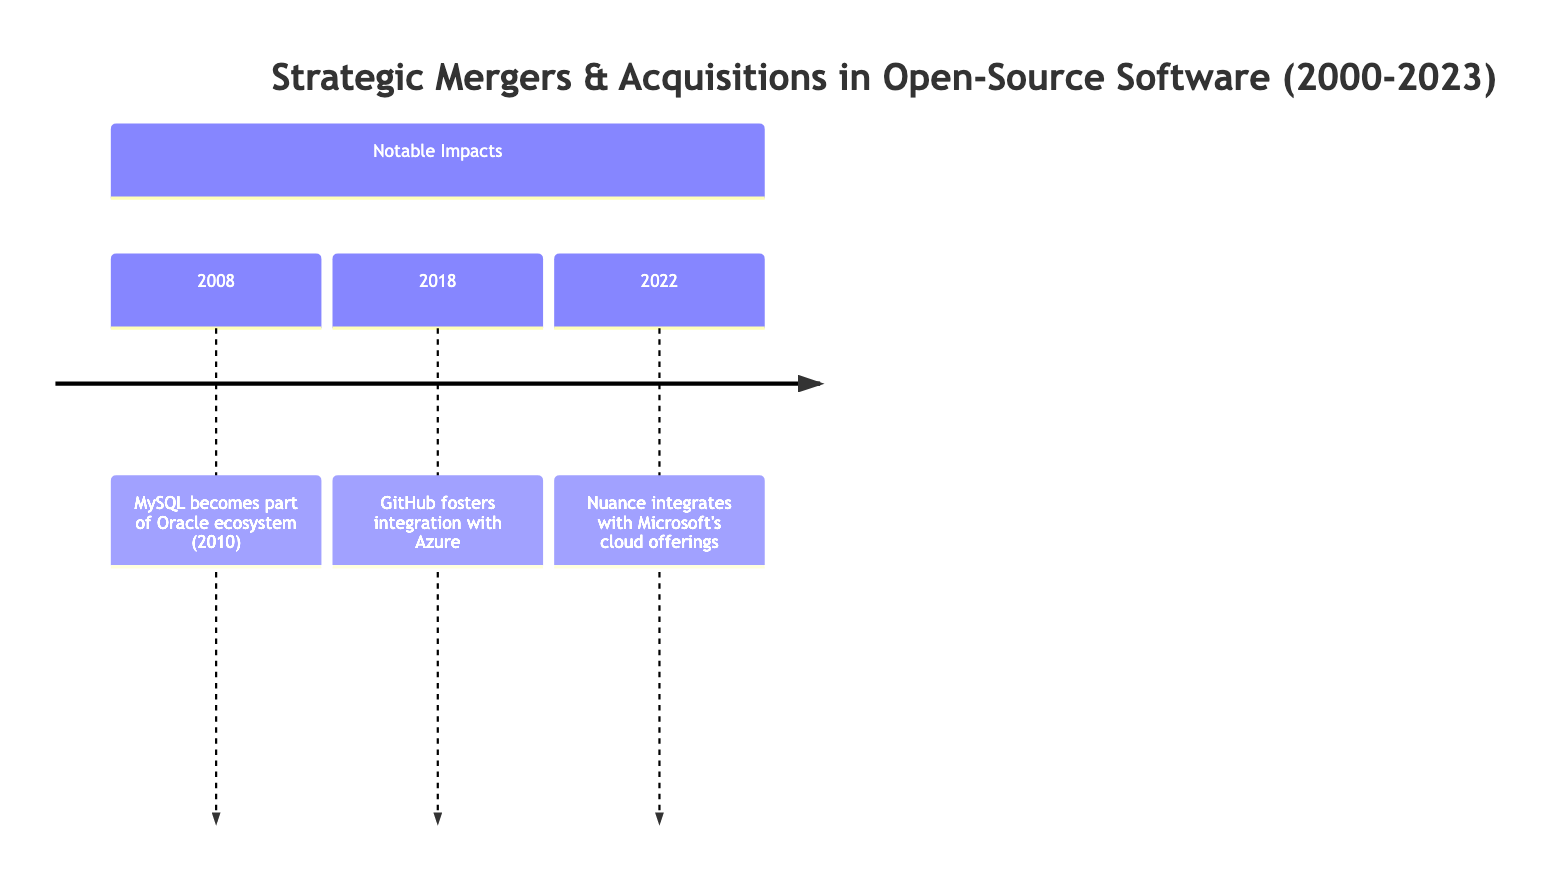What year did IBM acquire Informix? The timeline indicates that IBM acquired Informix in the year 2001.
Answer: 2001 What was the impact of Microsoft's acquisition of GitHub? The diagram states that Microsoft's acquisition of GitHub expanded developer tools and cloud services, facilitating greater integration with Azure and other Microsoft services.
Answer: Expanded developer tools and services How many acquisitions did Microsoft make in this timeline? Upon reviewing the timeline, Microsoft made three acquisitions: Revolution Analytics in 2015, GitHub in 2018, and Nuance Communications in 2022.
Answer: 3 Which company was acquired by Sun Microsystems? The timeline shows that Sun Microsystems acquired MySQL AB in 2008.
Answer: MySQL AB What was a notable impact of IBM’s acquisition of Red Hat? According to the diagram, IBM's $34 billion acquisition of Red Hat significantly bolstered IBM's hybrid cloud solutions, reshaping enterprise cloud services.
Answer: Reshaping enterprise cloud services What year did Red Hat acquire eNovance? The timeline indicates that Red Hat acquired eNovance in 2014.
Answer: 2014 What was the purpose of VMware acquiring SpringSource in 2010? From the timeline, VMware’s acquisition of SpringSource was aimed at expanding its open-source software capabilities, particularly improving cloud computing and enterprise solutions.
Answer: Expanding cloud computing capabilities Which acquisition marked a significant transformation in the database market in 2008? The timeline remarks that Sun Microsystems' acquisition of MySQL AB in 2008 was significant as it integrated MySQL into Oracle's ecosystem in 2010, transforming the database market.
Answer: MySQL AB What appears to be the impact of Google’s acquisition of Elastifile? The diagram notes that Google's acquisition of Elastifile enhanced its cloud storage solutions by improving Google Cloud's storage capabilities through open-source-compatible software.
Answer: Enhancing cloud storage solutions 